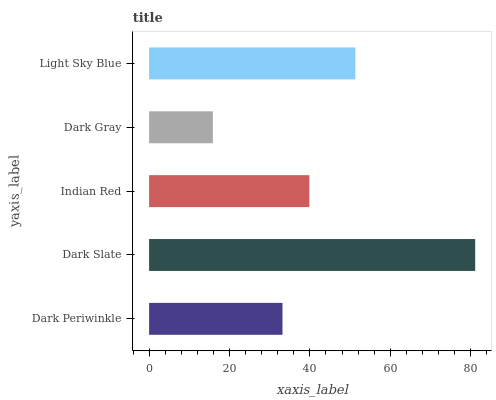Is Dark Gray the minimum?
Answer yes or no. Yes. Is Dark Slate the maximum?
Answer yes or no. Yes. Is Indian Red the minimum?
Answer yes or no. No. Is Indian Red the maximum?
Answer yes or no. No. Is Dark Slate greater than Indian Red?
Answer yes or no. Yes. Is Indian Red less than Dark Slate?
Answer yes or no. Yes. Is Indian Red greater than Dark Slate?
Answer yes or no. No. Is Dark Slate less than Indian Red?
Answer yes or no. No. Is Indian Red the high median?
Answer yes or no. Yes. Is Indian Red the low median?
Answer yes or no. Yes. Is Light Sky Blue the high median?
Answer yes or no. No. Is Light Sky Blue the low median?
Answer yes or no. No. 